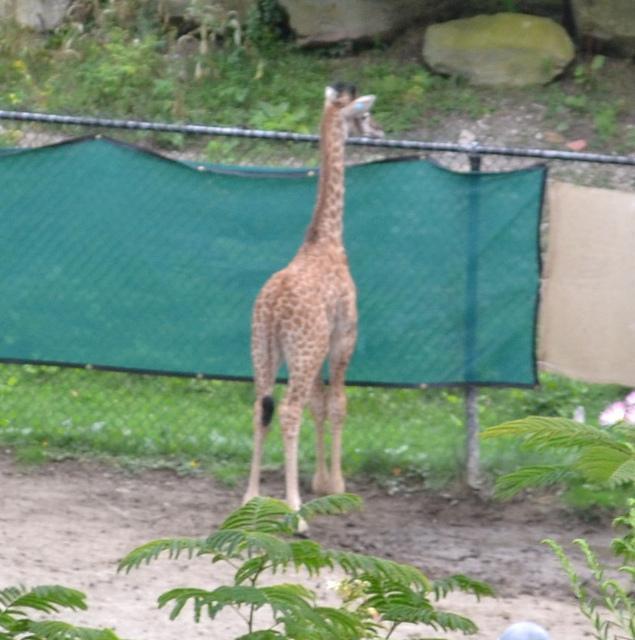How many legs does this animal have?
Give a very brief answer. 4. 